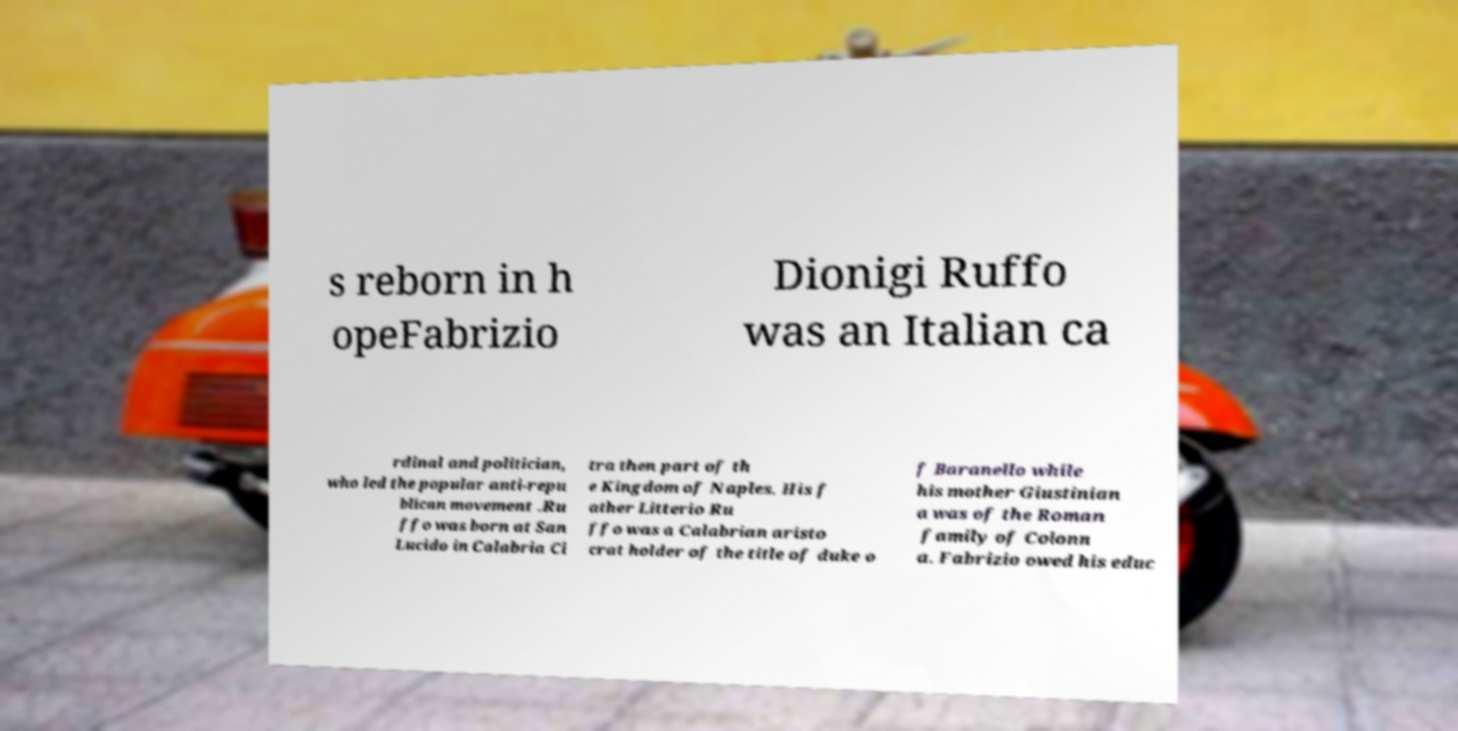Please read and relay the text visible in this image. What does it say? s reborn in h opeFabrizio Dionigi Ruffo was an Italian ca rdinal and politician, who led the popular anti-repu blican movement .Ru ffo was born at San Lucido in Calabria Ci tra then part of th e Kingdom of Naples. His f ather Litterio Ru ffo was a Calabrian aristo crat holder of the title of duke o f Baranello while his mother Giustinian a was of the Roman family of Colonn a. Fabrizio owed his educ 